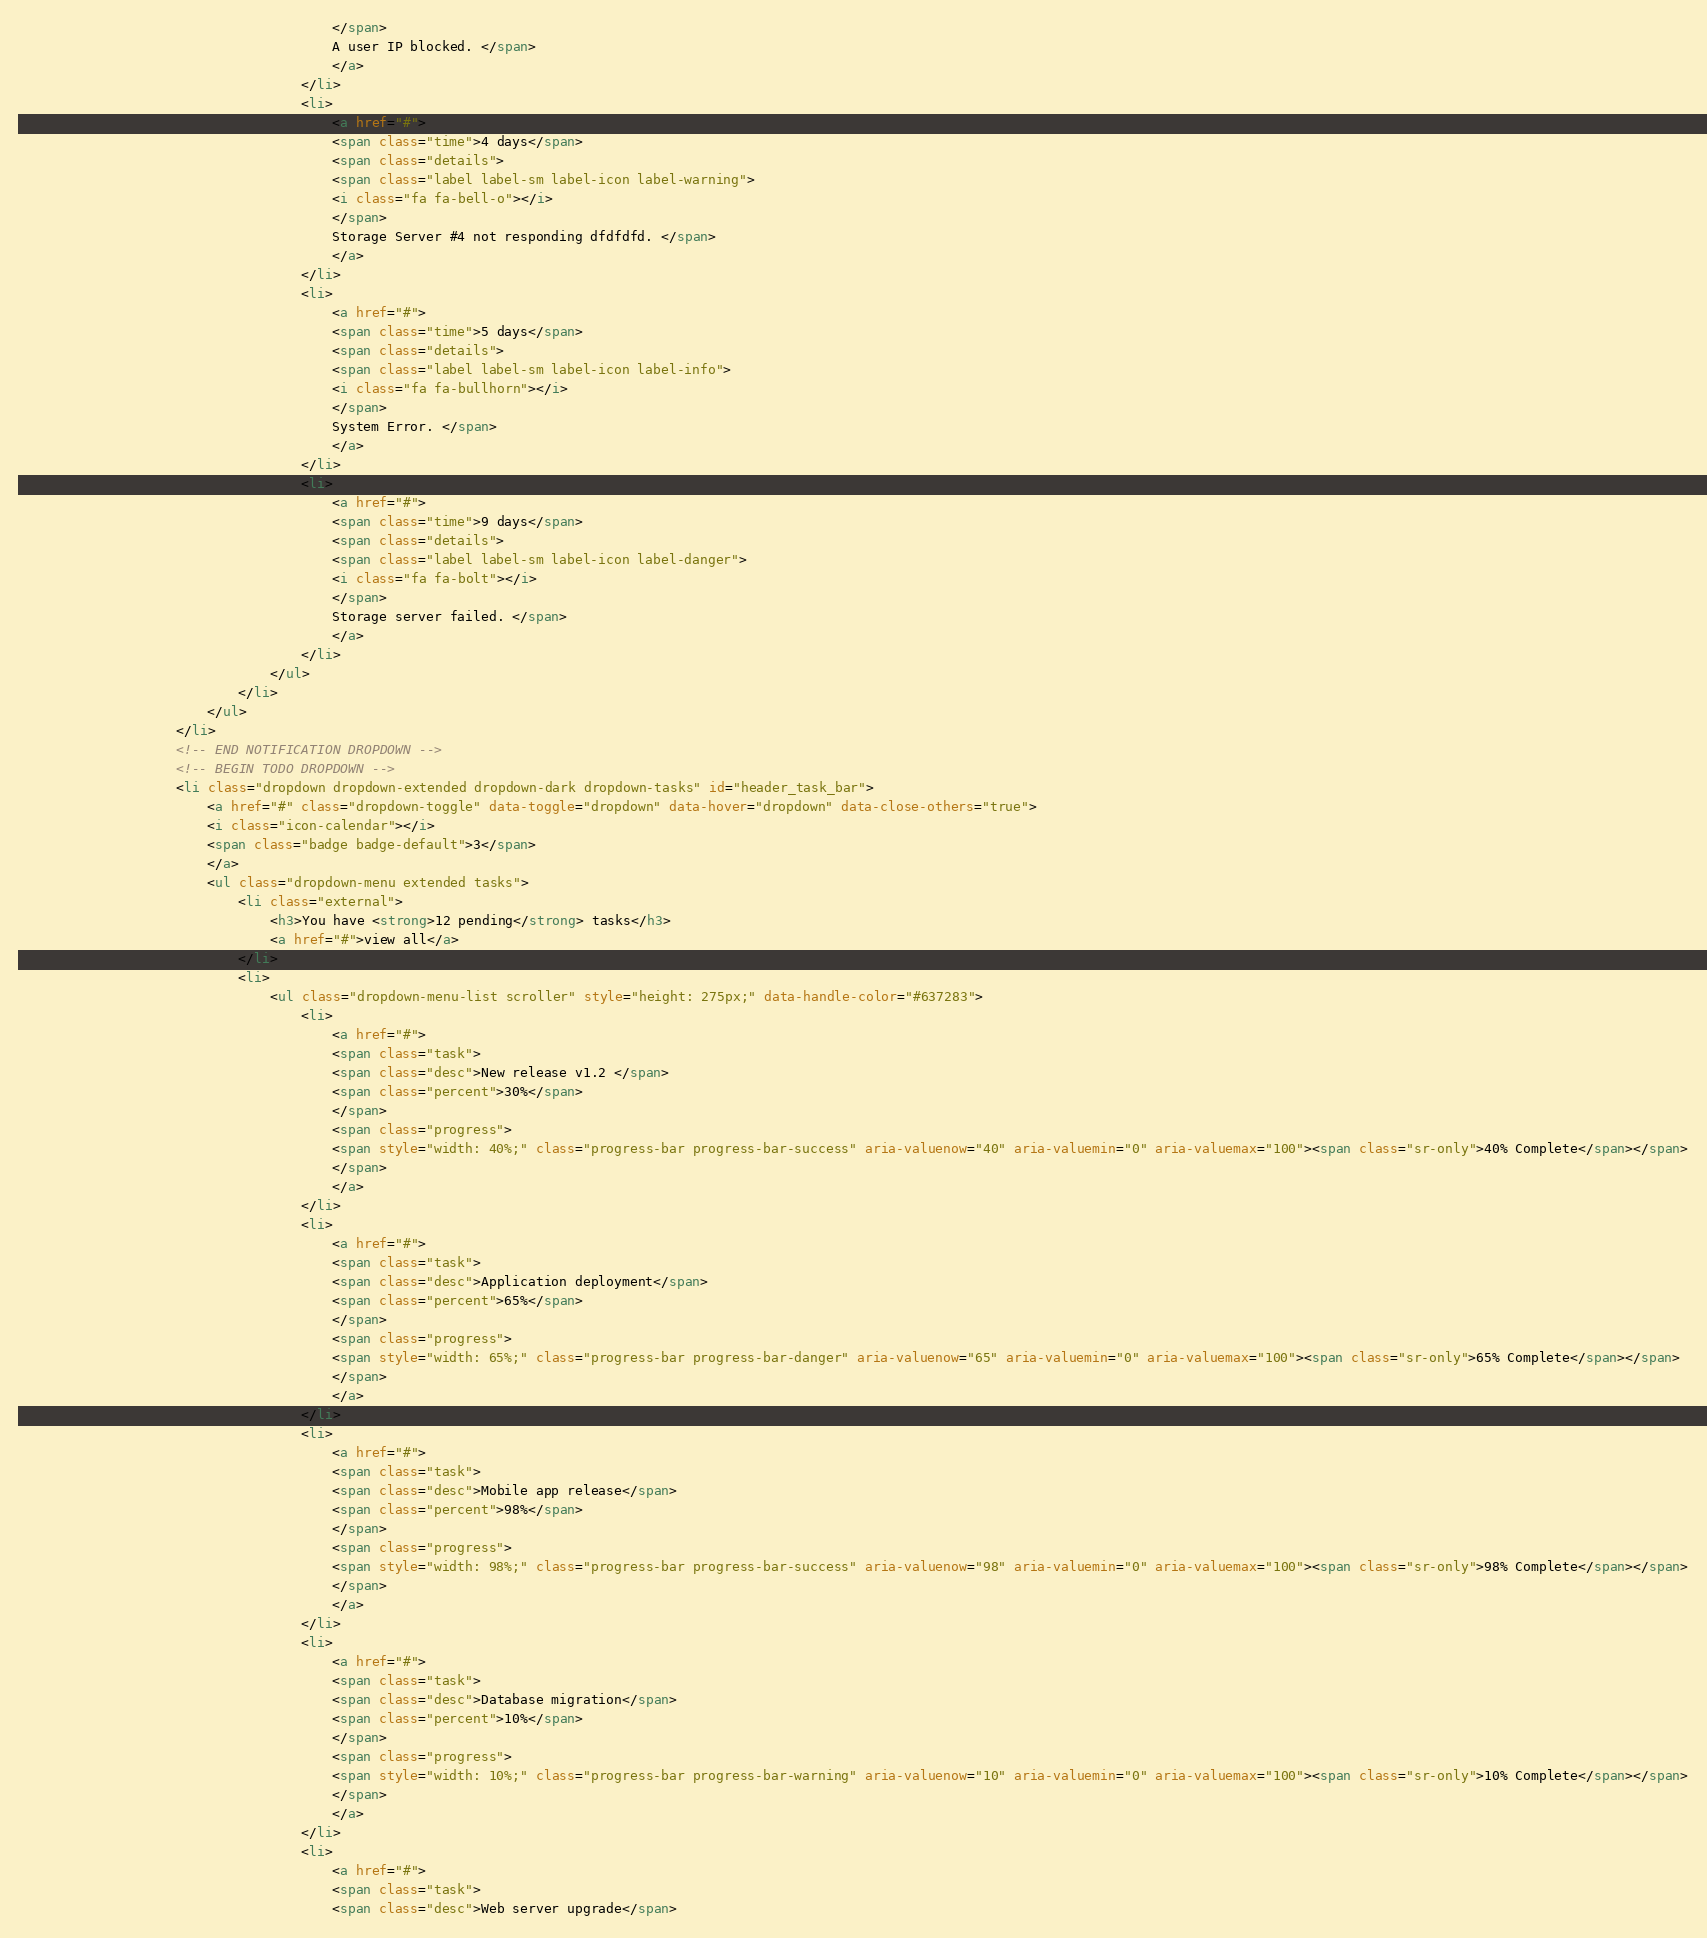Convert code to text. <code><loc_0><loc_0><loc_500><loc_500><_HTML_>										</span>
										A user IP blocked. </span>
										</a>
									</li>
									<li>
										<a href="#">
										<span class="time">4 days</span>
										<span class="details">
										<span class="label label-sm label-icon label-warning">
										<i class="fa fa-bell-o"></i>
										</span>
										Storage Server #4 not responding dfdfdfd. </span>
										</a>
									</li>
									<li>
										<a href="#">
										<span class="time">5 days</span>
										<span class="details">
										<span class="label label-sm label-icon label-info">
										<i class="fa fa-bullhorn"></i>
										</span>
										System Error. </span>
										</a>
									</li>
									<li>
										<a href="#">
										<span class="time">9 days</span>
										<span class="details">
										<span class="label label-sm label-icon label-danger">
										<i class="fa fa-bolt"></i>
										</span>
										Storage server failed. </span>
										</a>
									</li>
								</ul>
							</li>
						</ul>
					</li>
					<!-- END NOTIFICATION DROPDOWN -->
					<!-- BEGIN TODO DROPDOWN -->
					<li class="dropdown dropdown-extended dropdown-dark dropdown-tasks" id="header_task_bar">
						<a href="#" class="dropdown-toggle" data-toggle="dropdown" data-hover="dropdown" data-close-others="true">
						<i class="icon-calendar"></i>
						<span class="badge badge-default">3</span>
						</a>
						<ul class="dropdown-menu extended tasks">
							<li class="external">
								<h3>You have <strong>12 pending</strong> tasks</h3>
								<a href="#">view all</a>
							</li>
							<li>
								<ul class="dropdown-menu-list scroller" style="height: 275px;" data-handle-color="#637283">
									<li>
										<a href="#">
										<span class="task">
										<span class="desc">New release v1.2 </span>
										<span class="percent">30%</span>
										</span>
										<span class="progress">
										<span style="width: 40%;" class="progress-bar progress-bar-success" aria-valuenow="40" aria-valuemin="0" aria-valuemax="100"><span class="sr-only">40% Complete</span></span>
										</span>
										</a>
									</li>
									<li>
										<a href="#">
										<span class="task">
										<span class="desc">Application deployment</span>
										<span class="percent">65%</span>
										</span>
										<span class="progress">
										<span style="width: 65%;" class="progress-bar progress-bar-danger" aria-valuenow="65" aria-valuemin="0" aria-valuemax="100"><span class="sr-only">65% Complete</span></span>
										</span>
										</a>
									</li>
									<li>
										<a href="#">
										<span class="task">
										<span class="desc">Mobile app release</span>
										<span class="percent">98%</span>
										</span>
										<span class="progress">
										<span style="width: 98%;" class="progress-bar progress-bar-success" aria-valuenow="98" aria-valuemin="0" aria-valuemax="100"><span class="sr-only">98% Complete</span></span>
										</span>
										</a>
									</li>
									<li>
										<a href="#">
										<span class="task">
										<span class="desc">Database migration</span>
										<span class="percent">10%</span>
										</span>
										<span class="progress">
										<span style="width: 10%;" class="progress-bar progress-bar-warning" aria-valuenow="10" aria-valuemin="0" aria-valuemax="100"><span class="sr-only">10% Complete</span></span>
										</span>
										</a>
									</li>
									<li>
										<a href="#">
										<span class="task">
										<span class="desc">Web server upgrade</span></code> 